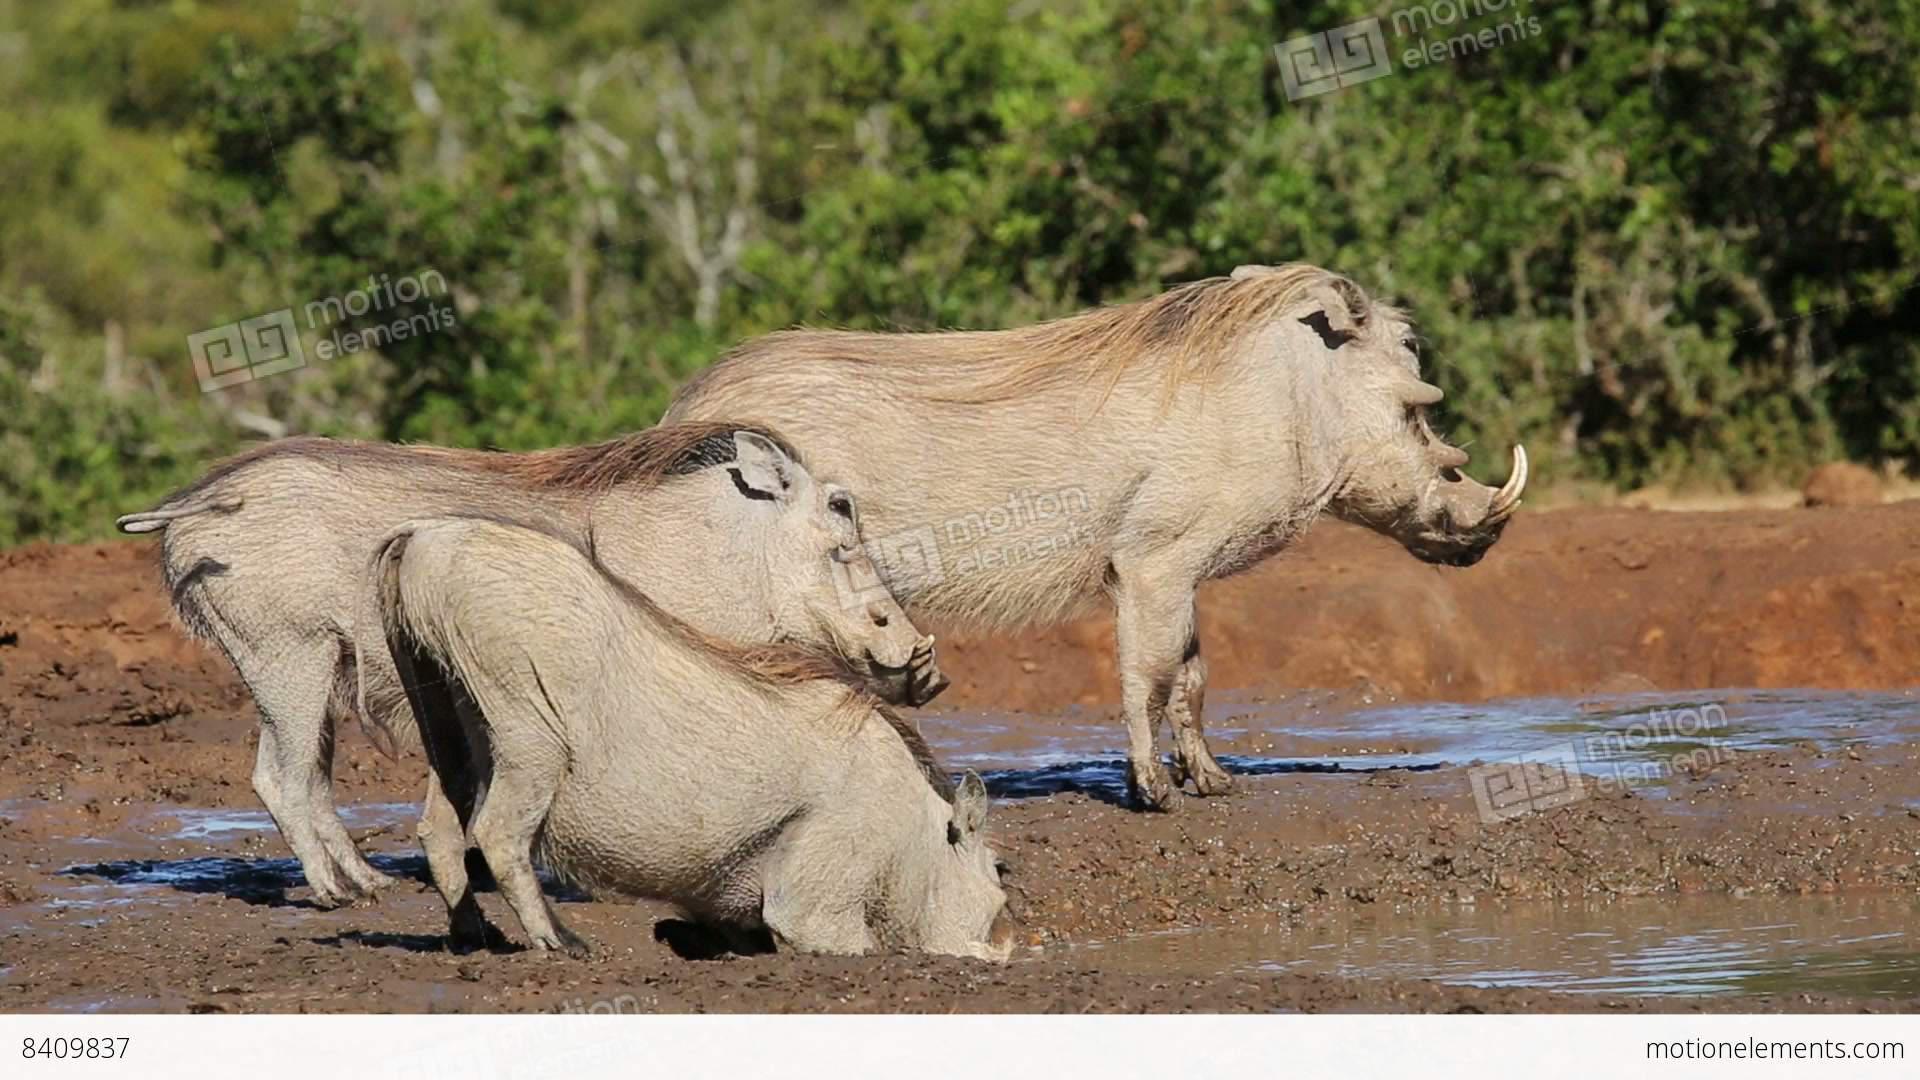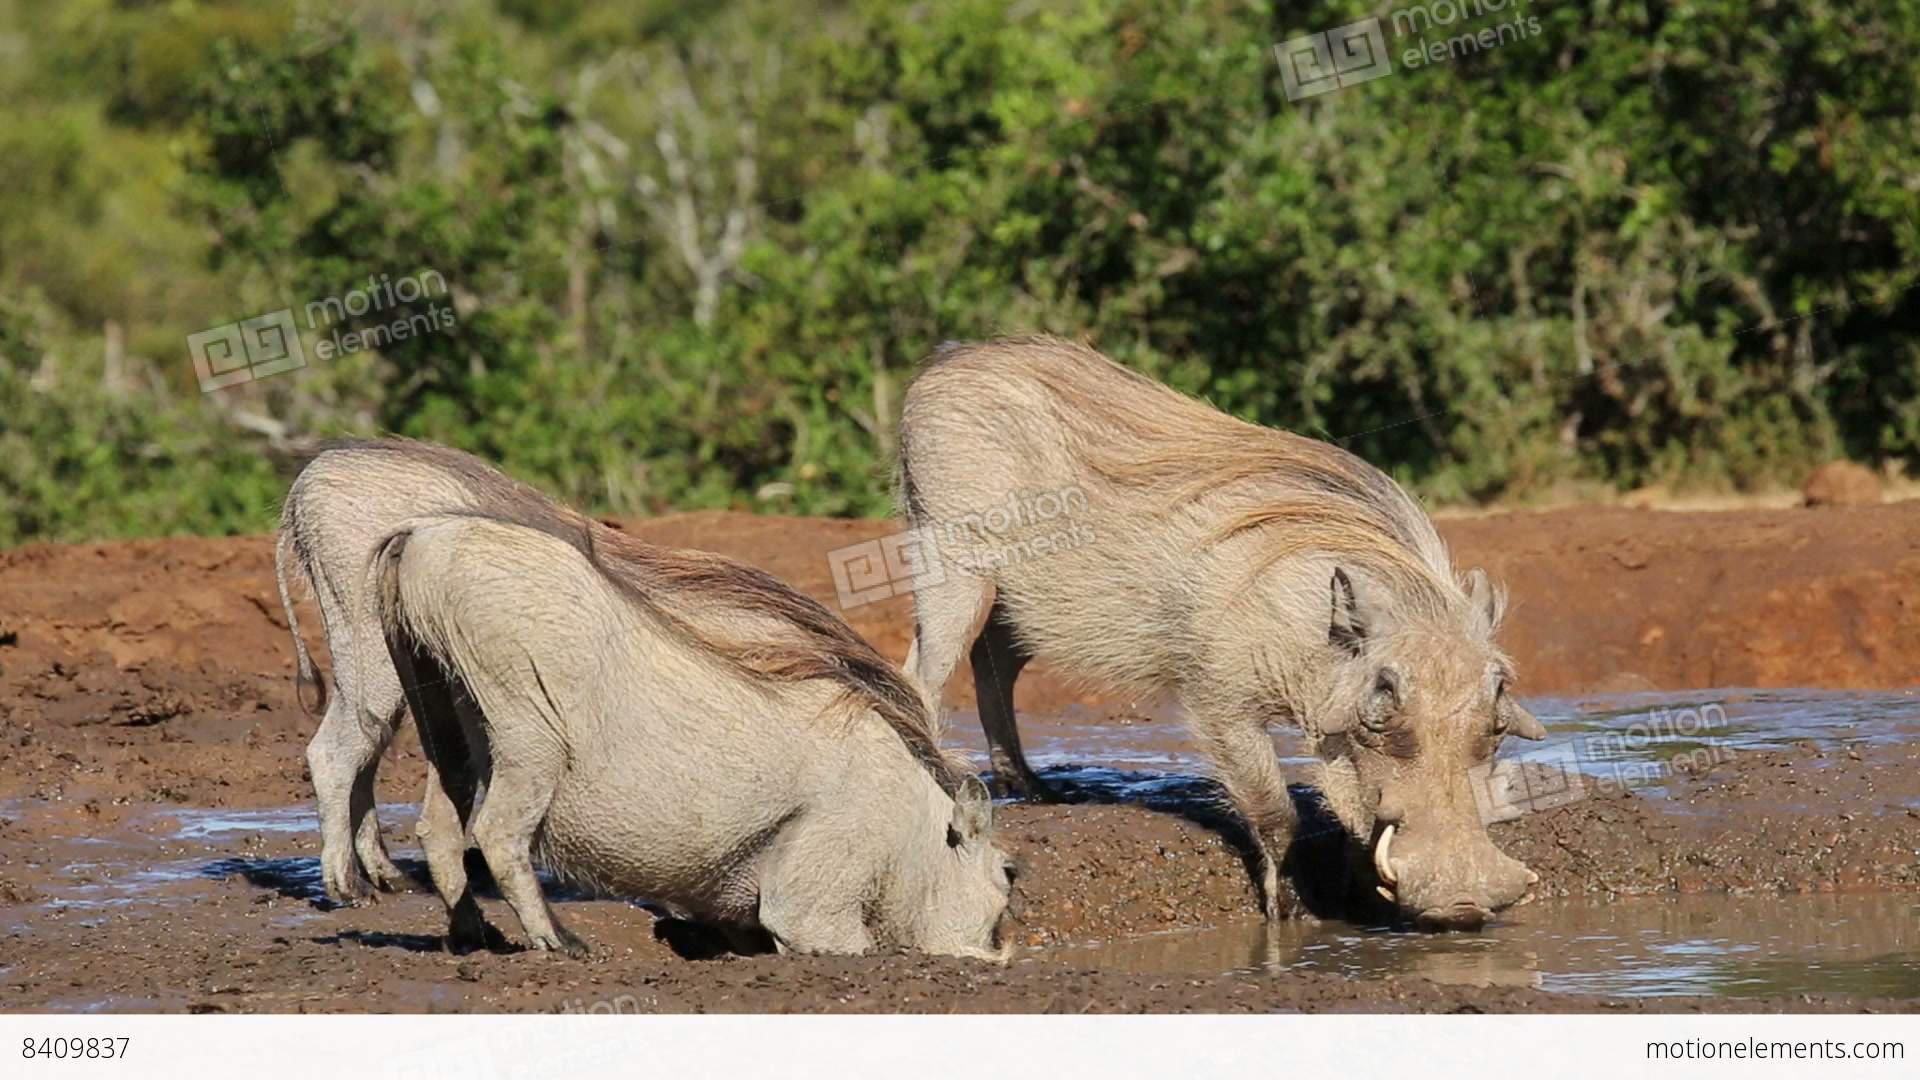The first image is the image on the left, the second image is the image on the right. Given the left and right images, does the statement "There are at most four warthogs." hold true? Answer yes or no. No. 